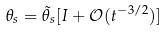<formula> <loc_0><loc_0><loc_500><loc_500>\theta _ { s } = \tilde { \theta } _ { s } [ I + \mathcal { O } ( t ^ { - 3 / 2 } ) ]</formula> 